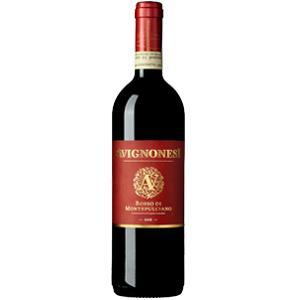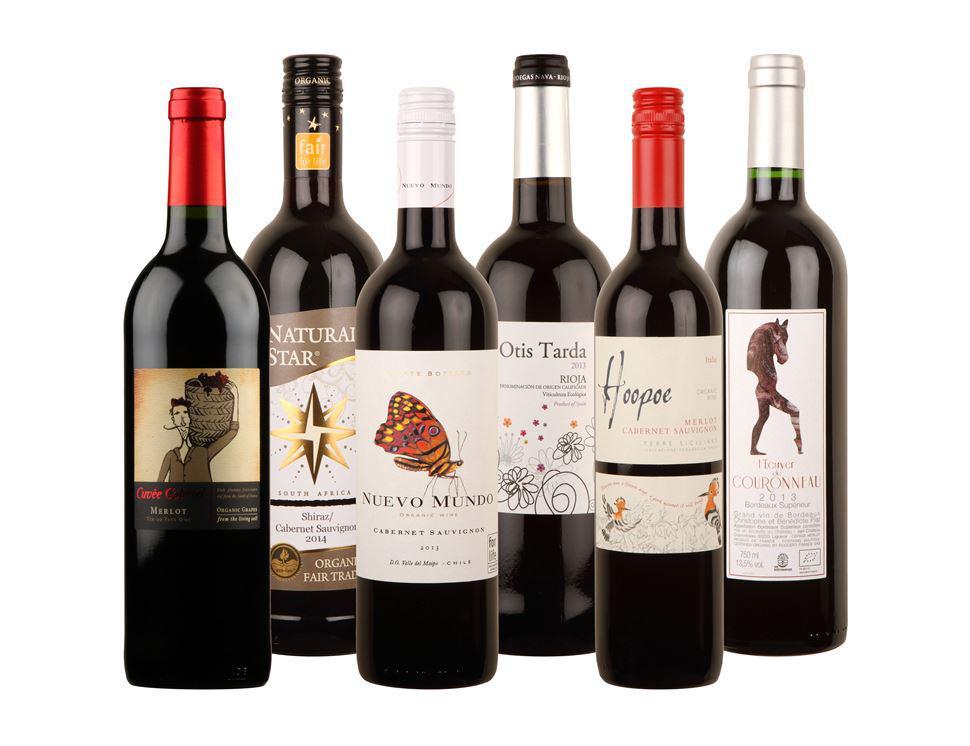The first image is the image on the left, the second image is the image on the right. Analyze the images presented: Is the assertion "An image includes at least one wine bottle and wine glass." valid? Answer yes or no. No. The first image is the image on the left, the second image is the image on the right. For the images shown, is this caption "A single bottle of wine is shown in one image." true? Answer yes or no. Yes. 